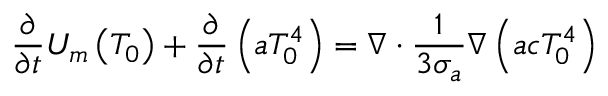<formula> <loc_0><loc_0><loc_500><loc_500>\frac { \partial } { \partial t } U _ { m } \left ( T _ { 0 } \right ) + \frac { \partial } { \partial t } \left ( a T _ { 0 } ^ { 4 } \right ) = \nabla \cdot \frac { 1 } { 3 \sigma _ { a } } \nabla \left ( a c T _ { 0 } ^ { 4 } \right )</formula> 